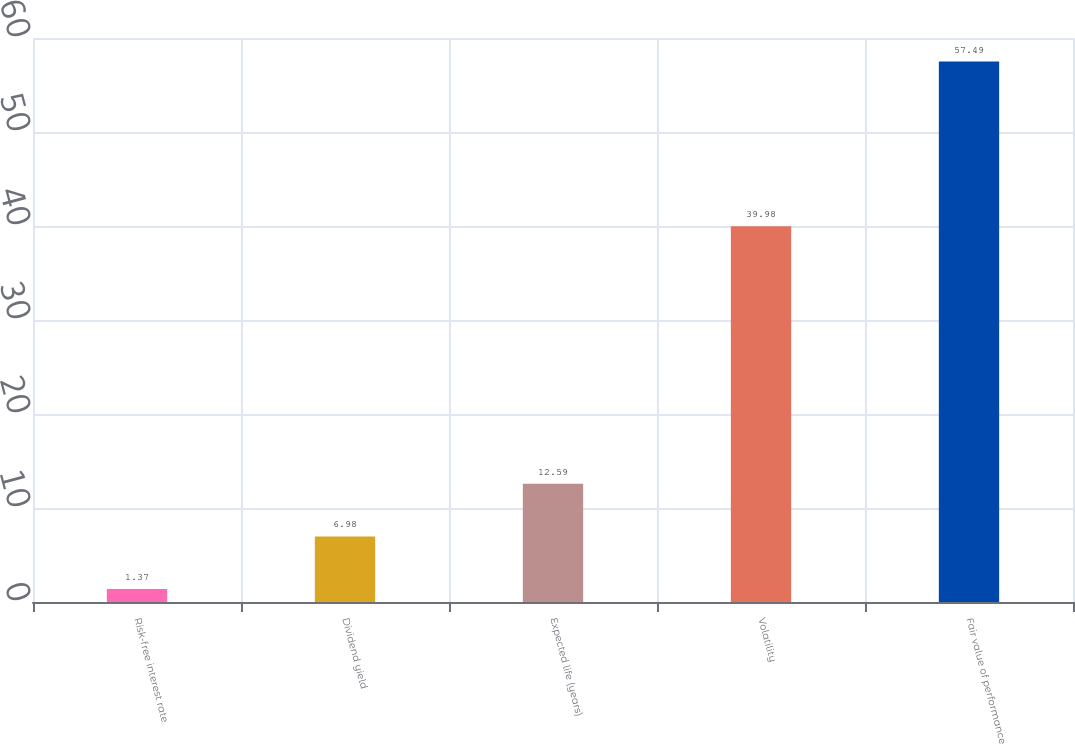Convert chart. <chart><loc_0><loc_0><loc_500><loc_500><bar_chart><fcel>Risk-free interest rate<fcel>Dividend yield<fcel>Expected life (years)<fcel>Volatility<fcel>Fair value of performance<nl><fcel>1.37<fcel>6.98<fcel>12.59<fcel>39.98<fcel>57.49<nl></chart> 